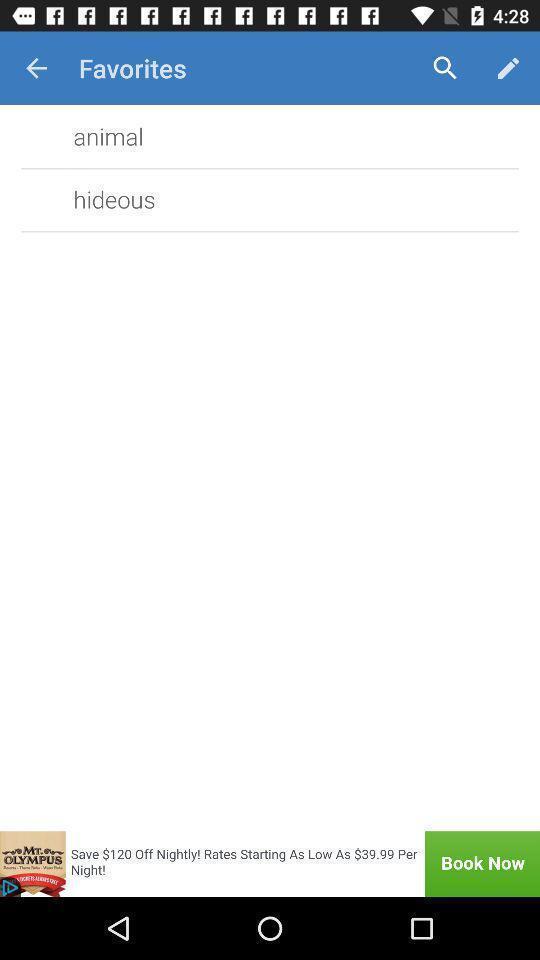Summarize the information in this screenshot. Page showing favorites option. 